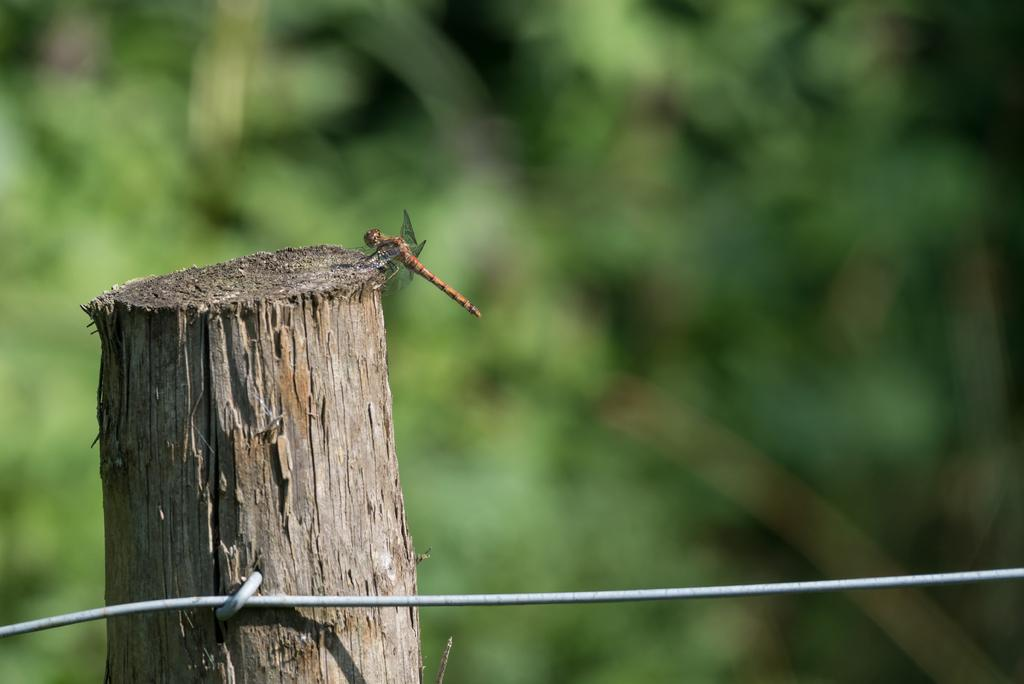What type of insect is present in the image? There is a fly in the image. What material is visible in the image? There is bark in the image. What color dominates the background of the image? The background of the image is green. What is the health status of the fly in the image? There is no information about the health status of the fly in the image. What is the texture of the bark in the image? The texture of the bark cannot be determined from the image alone. 